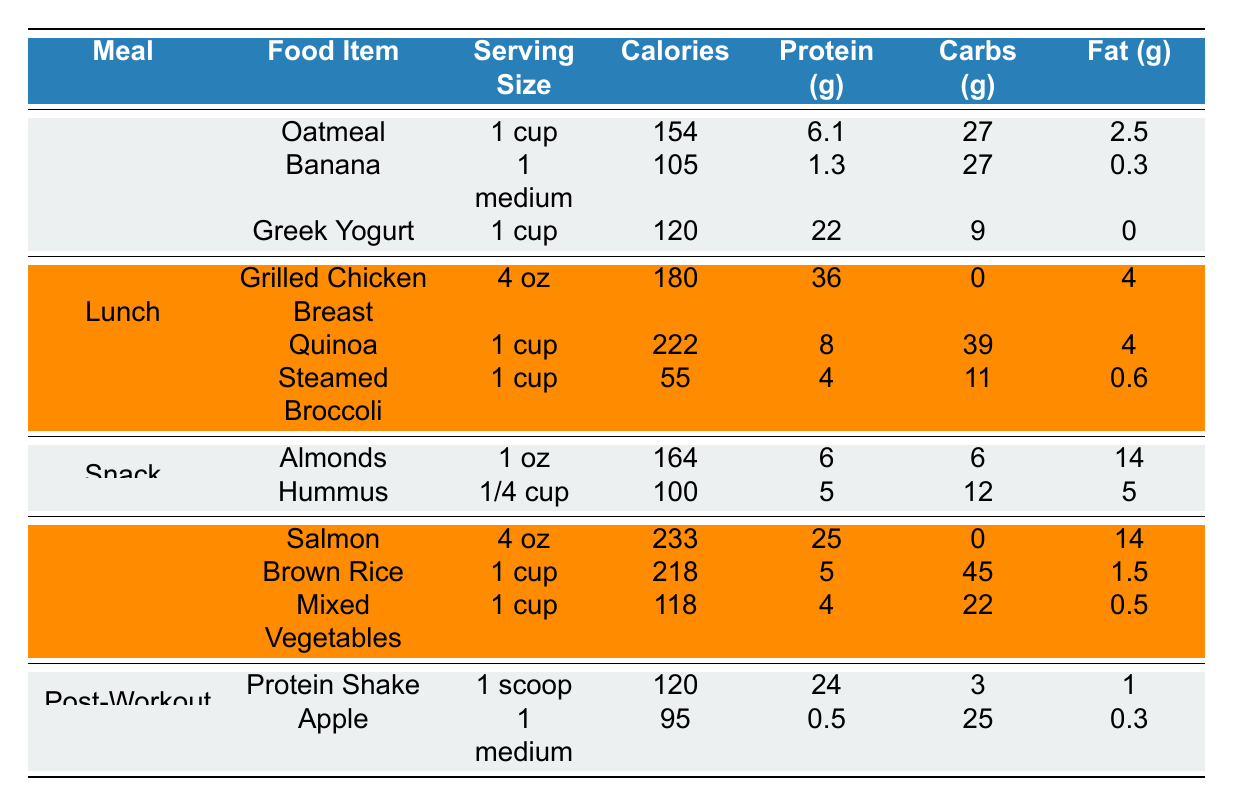What's the total protein content in breakfast? The breakfast meal includes three items: Oatmeal (6.1g), Banana (1.3g), and Greek Yogurt (22g). Adding these protein values together: 6.1 + 1.3 + 22 = 29.4g.
Answer: 29.4g Which food item has the highest calorie count in the lunch section? The lunch section contains three items: Grilled Chicken Breast (180 calories), Quinoa (222 calories), and Steamed Broccoli (55 calories). Quinoa has the highest calorie count with 222 calories.
Answer: Quinoa Does the snack portion contain any food items that have a lower fat content than hummus? Hummus has a fat content of 5g. The other snack item, Almonds, has a fat content of 14g. Since 14g is greater, there are no items with lower fat content in the snack portion than Hummus.
Answer: No What is the total carbohydrate content in the dinner section? The dinner section includes three items: Salmon (0g carbohydrates), Brown Rice (45g carbohydrates), and Mixed Vegetables (22g carbohydrates). Adding together the carbohydrate amounts gives us 0 + 45 + 22 = 67g.
Answer: 67g If a player consumes all the food items from lunch, how much protein would they get in total? The lunch meal includes Grilled Chicken Breast (36g protein), Quinoa (8g protein), and Steamed Broccoli (4g protein). Summing these values results in 36 + 8 + 4 = 48g of protein.
Answer: 48g Is there any meal that contains a food item with zero fat? In the breakfast section, Greek Yogurt has a fat content of 0g. Therefore, there is a meal that contains a food item with zero fat.
Answer: Yes What is the average calorie content of the food items in the post-workout meal? The post-workout meal includes two items: Protein Shake (120 calories) and Apple (95 calories). The average calorie count is calculated by adding the calorie values (120 + 95 = 215) and dividing by the number of items (215/2 = 107.5).
Answer: 107.5 Which meal options include a food item that is a source of protein greater than 20g? Upon reviewing the meals, Greek Yogurt from breakfast contains 22g of protein, and the Protein Shake from the post-workout meal contains 24g of protein. Both of these items satisfy the condition of being greater than 20g.
Answer: Breakfast and Post-Workout What item has the highest fiber content among all meals? Evaluating the fiber content: Oatmeal (4g), Banana (3.1g), Greek Yogurt (0g), Grilled Chicken Breast (0g), Quinoa (5g), Steamed Broccoli (5g), Almonds (3.5g), Hummus (4g), Salmon (0g), Brown Rice (3.5g), Mixed Vegetables (5g), Protein Shake (1g), and Apple (4g). The maximum fiber content is found in Quinoa, Steamed Broccoli, and Mixed Vegetables, each with 5g.
Answer: Quinoa, Steamed Broccoli, Mixed Vegetables 